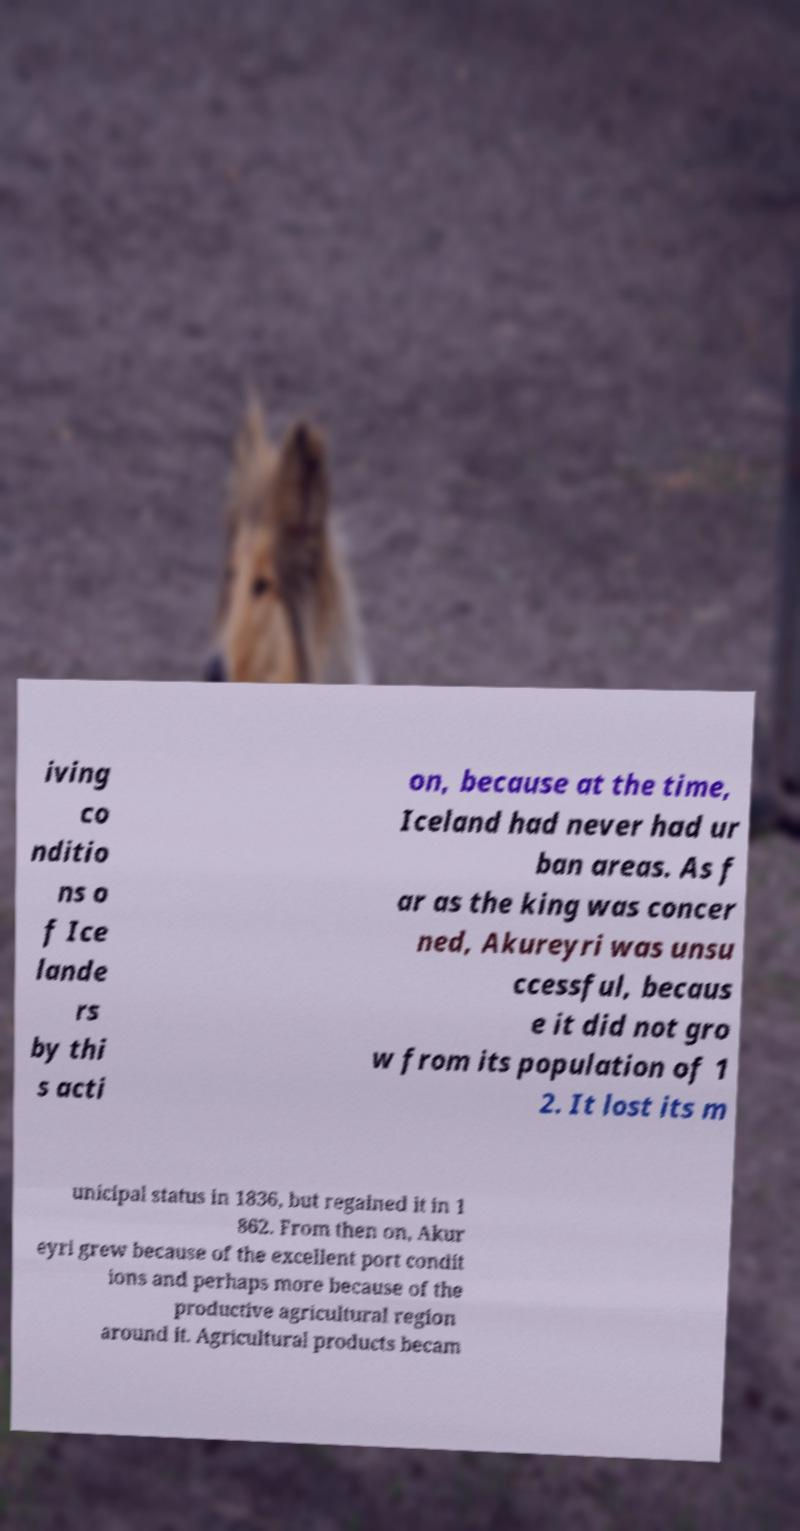There's text embedded in this image that I need extracted. Can you transcribe it verbatim? iving co nditio ns o f Ice lande rs by thi s acti on, because at the time, Iceland had never had ur ban areas. As f ar as the king was concer ned, Akureyri was unsu ccessful, becaus e it did not gro w from its population of 1 2. It lost its m unicipal status in 1836, but regained it in 1 862. From then on, Akur eyri grew because of the excellent port condit ions and perhaps more because of the productive agricultural region around it. Agricultural products becam 